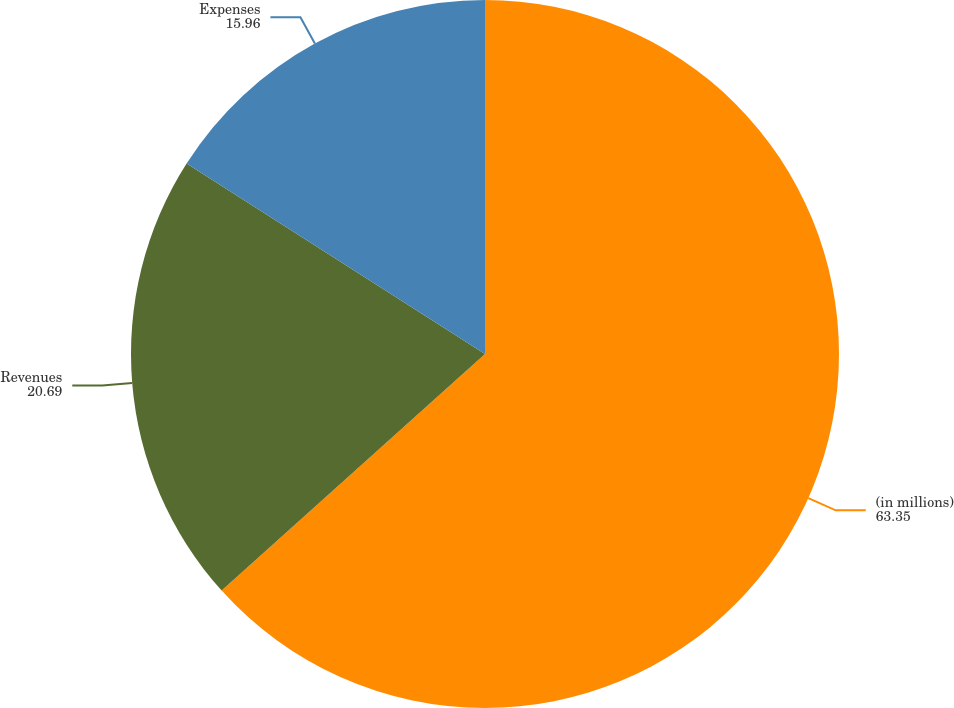Convert chart to OTSL. <chart><loc_0><loc_0><loc_500><loc_500><pie_chart><fcel>(in millions)<fcel>Revenues<fcel>Expenses<nl><fcel>63.35%<fcel>20.69%<fcel>15.96%<nl></chart> 